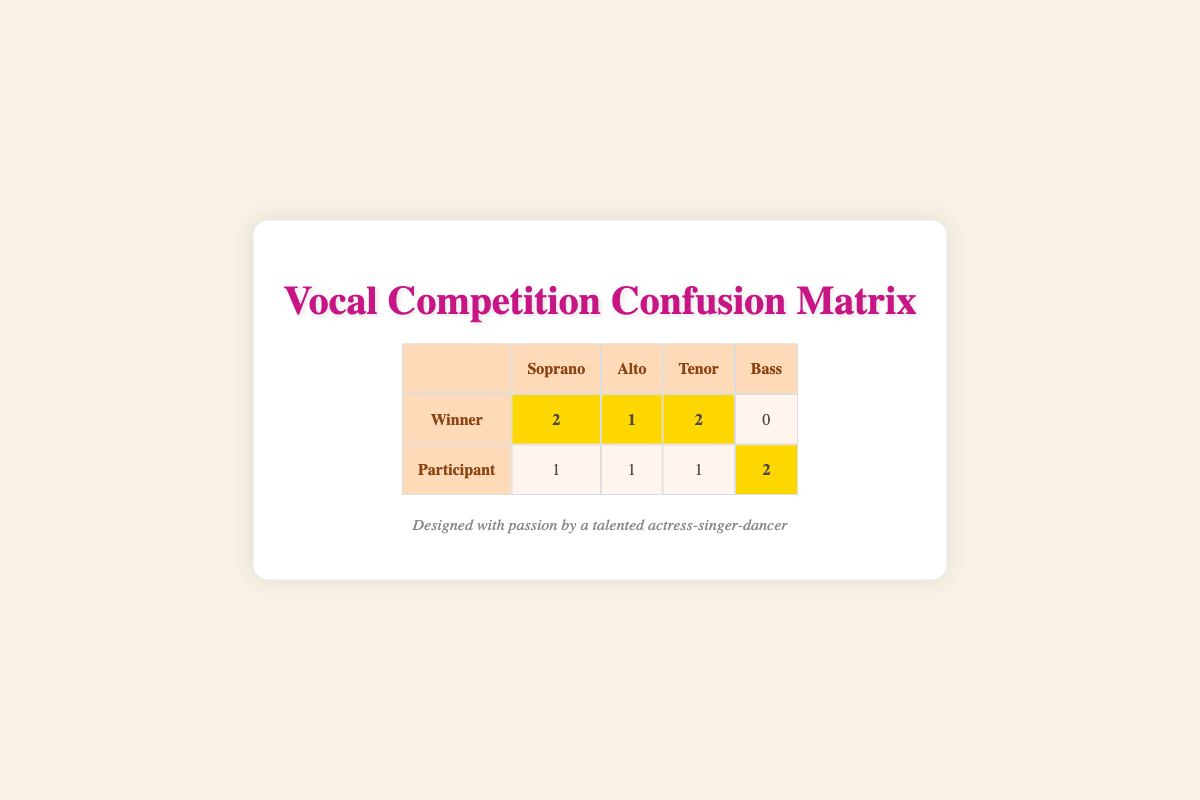What is the total number of winners in the soprano vocal range? The table shows that there are 2 winners in the soprano vocal range, as indicated in the "Winner" row under the "Soprano" column.
Answer: 2 How many participants are categorized as bass? In the "Participant" row, the table shows there are 2 participants in the bass vocal range, as noted in the "Bass" column.
Answer: 2 What is the total number of winners and participants in the alto vocal range? There is 1 winner and 1 participant in the alto vocal range. Adding these together gives 1 + 1 = 2.
Answer: 2 Are there any participants in the bass vocal range who were also winners? The table shows that there are 0 winners in the bass vocal range, indicating that no participants from this category won the competition.
Answer: No Which vocal range has the highest number of winners? The winners in each vocal range are as follows: Soprano: 2, Alto: 1, Tenor: 2, and Bass: 0. The soprano and tenor vocal ranges tie for the highest number of winners, both with 2.
Answer: Soprano and Tenor How many total participants competed in the singing competition across all vocal ranges? The table indicates that there are 4 winners and 5 participants. To find the total number of participants, we add the two counts: 4 + 5 = 9.
Answer: 9 What percentage of tenor participants won the competition? There are 3 tenor participants: 2 winners and 1 participant. To find the percentage of winners: (2 winners / 3 participants) * 100 = 66.67%.
Answer: Approximately 66.67% How many total winners are not classified as either soprano or alto? The table states that there are 2 winners in the tenor range and 0 in the bass range. So there are a total of 2 winners not classified as soprano or alto.
Answer: 2 